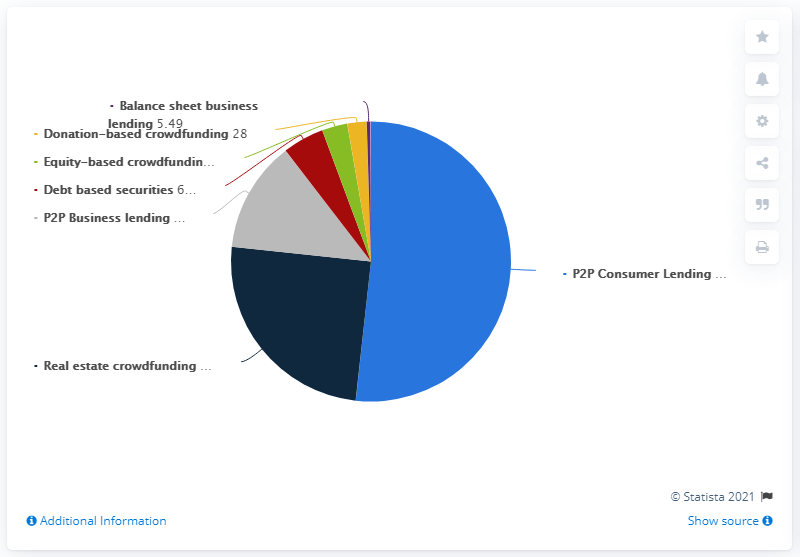Highlight a few significant elements in this photo. Seven platforms are considered in total. In 2018, the market value of peer-to-peer consumer lending in Germany was 651.3 million euros. The peer-to-peer consumer lending sector is more than 50% compared to other sectors. 